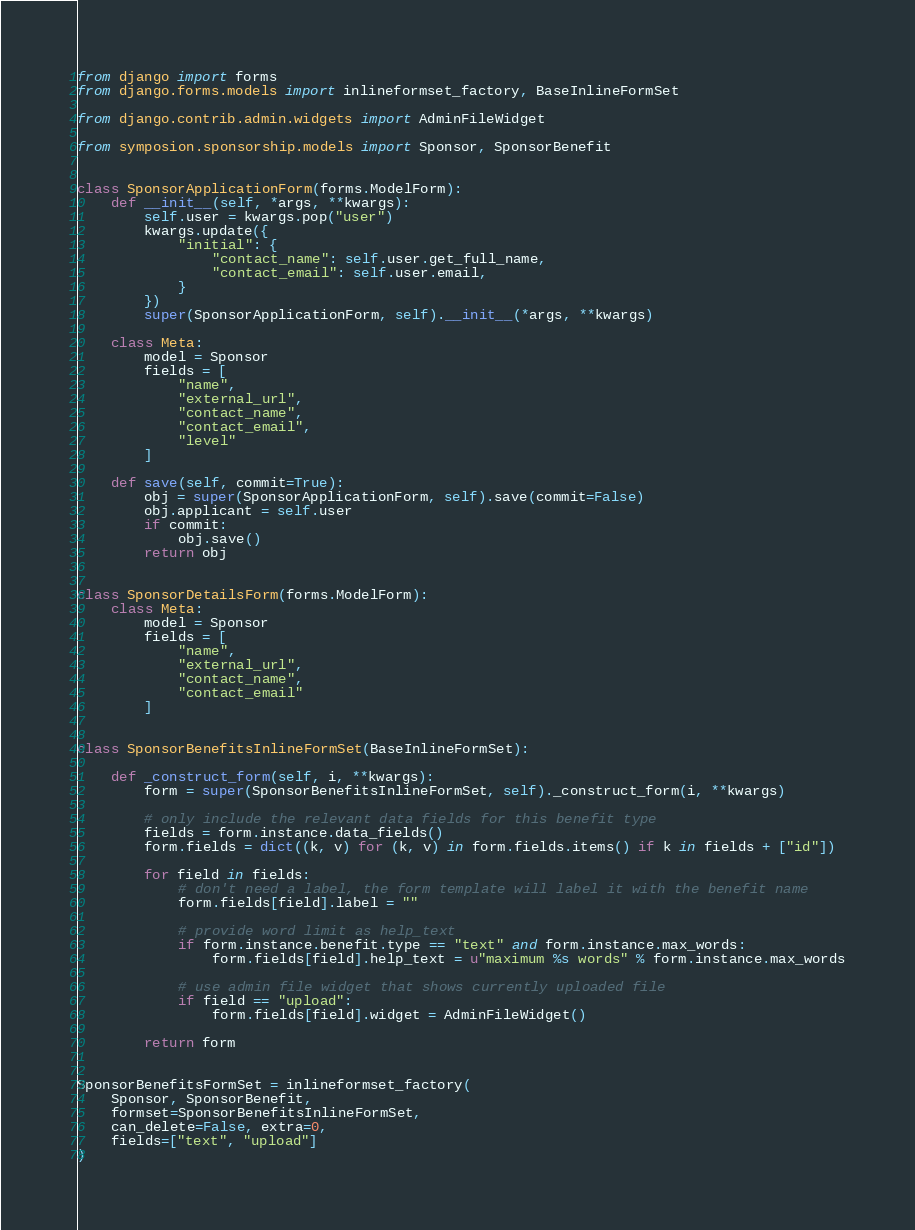<code> <loc_0><loc_0><loc_500><loc_500><_Python_>from django import forms
from django.forms.models import inlineformset_factory, BaseInlineFormSet

from django.contrib.admin.widgets import AdminFileWidget

from symposion.sponsorship.models import Sponsor, SponsorBenefit


class SponsorApplicationForm(forms.ModelForm):
    def __init__(self, *args, **kwargs):
        self.user = kwargs.pop("user")
        kwargs.update({
            "initial": {
                "contact_name": self.user.get_full_name,
                "contact_email": self.user.email,
            }
        })
        super(SponsorApplicationForm, self).__init__(*args, **kwargs)

    class Meta:
        model = Sponsor
        fields = [
            "name",
            "external_url",
            "contact_name",
            "contact_email",
            "level"
        ]

    def save(self, commit=True):
        obj = super(SponsorApplicationForm, self).save(commit=False)
        obj.applicant = self.user
        if commit:
            obj.save()
        return obj


class SponsorDetailsForm(forms.ModelForm):
    class Meta:
        model = Sponsor
        fields = [
            "name",
            "external_url",
            "contact_name",
            "contact_email"
        ]


class SponsorBenefitsInlineFormSet(BaseInlineFormSet):

    def _construct_form(self, i, **kwargs):
        form = super(SponsorBenefitsInlineFormSet, self)._construct_form(i, **kwargs)

        # only include the relevant data fields for this benefit type
        fields = form.instance.data_fields()
        form.fields = dict((k, v) for (k, v) in form.fields.items() if k in fields + ["id"])

        for field in fields:
            # don't need a label, the form template will label it with the benefit name
            form.fields[field].label = ""

            # provide word limit as help_text
            if form.instance.benefit.type == "text" and form.instance.max_words:
                form.fields[field].help_text = u"maximum %s words" % form.instance.max_words

            # use admin file widget that shows currently uploaded file
            if field == "upload":
                form.fields[field].widget = AdminFileWidget()

        return form


SponsorBenefitsFormSet = inlineformset_factory(
    Sponsor, SponsorBenefit,
    formset=SponsorBenefitsInlineFormSet,
    can_delete=False, extra=0,
    fields=["text", "upload"]
)
</code> 